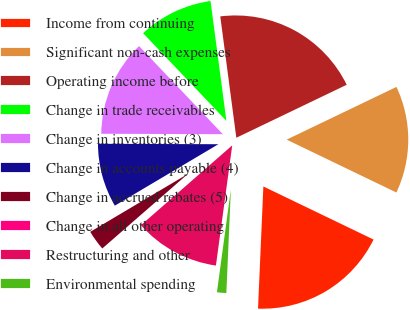Convert chart. <chart><loc_0><loc_0><loc_500><loc_500><pie_chart><fcel>Income from continuing<fcel>Significant non-cash expenses<fcel>Operating income before<fcel>Change in trade receivables<fcel>Change in inventories (3)<fcel>Change in accounts payable (4)<fcel>Change in accrued rebates (5)<fcel>Change in all other operating<fcel>Restructuring and other<fcel>Environmental spending<nl><fcel>18.55%<fcel>14.27%<fcel>19.97%<fcel>10.0%<fcel>12.85%<fcel>8.58%<fcel>2.88%<fcel>0.03%<fcel>11.42%<fcel>1.45%<nl></chart> 